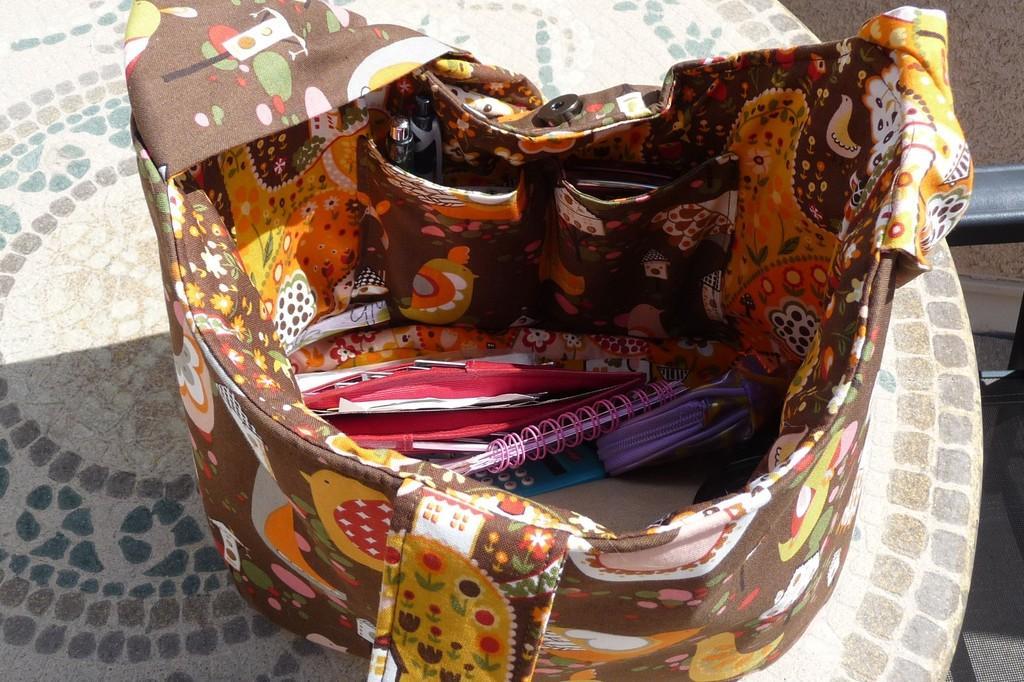Describe this image in one or two sentences. This is a handbag in which there are books,pens,etc. 